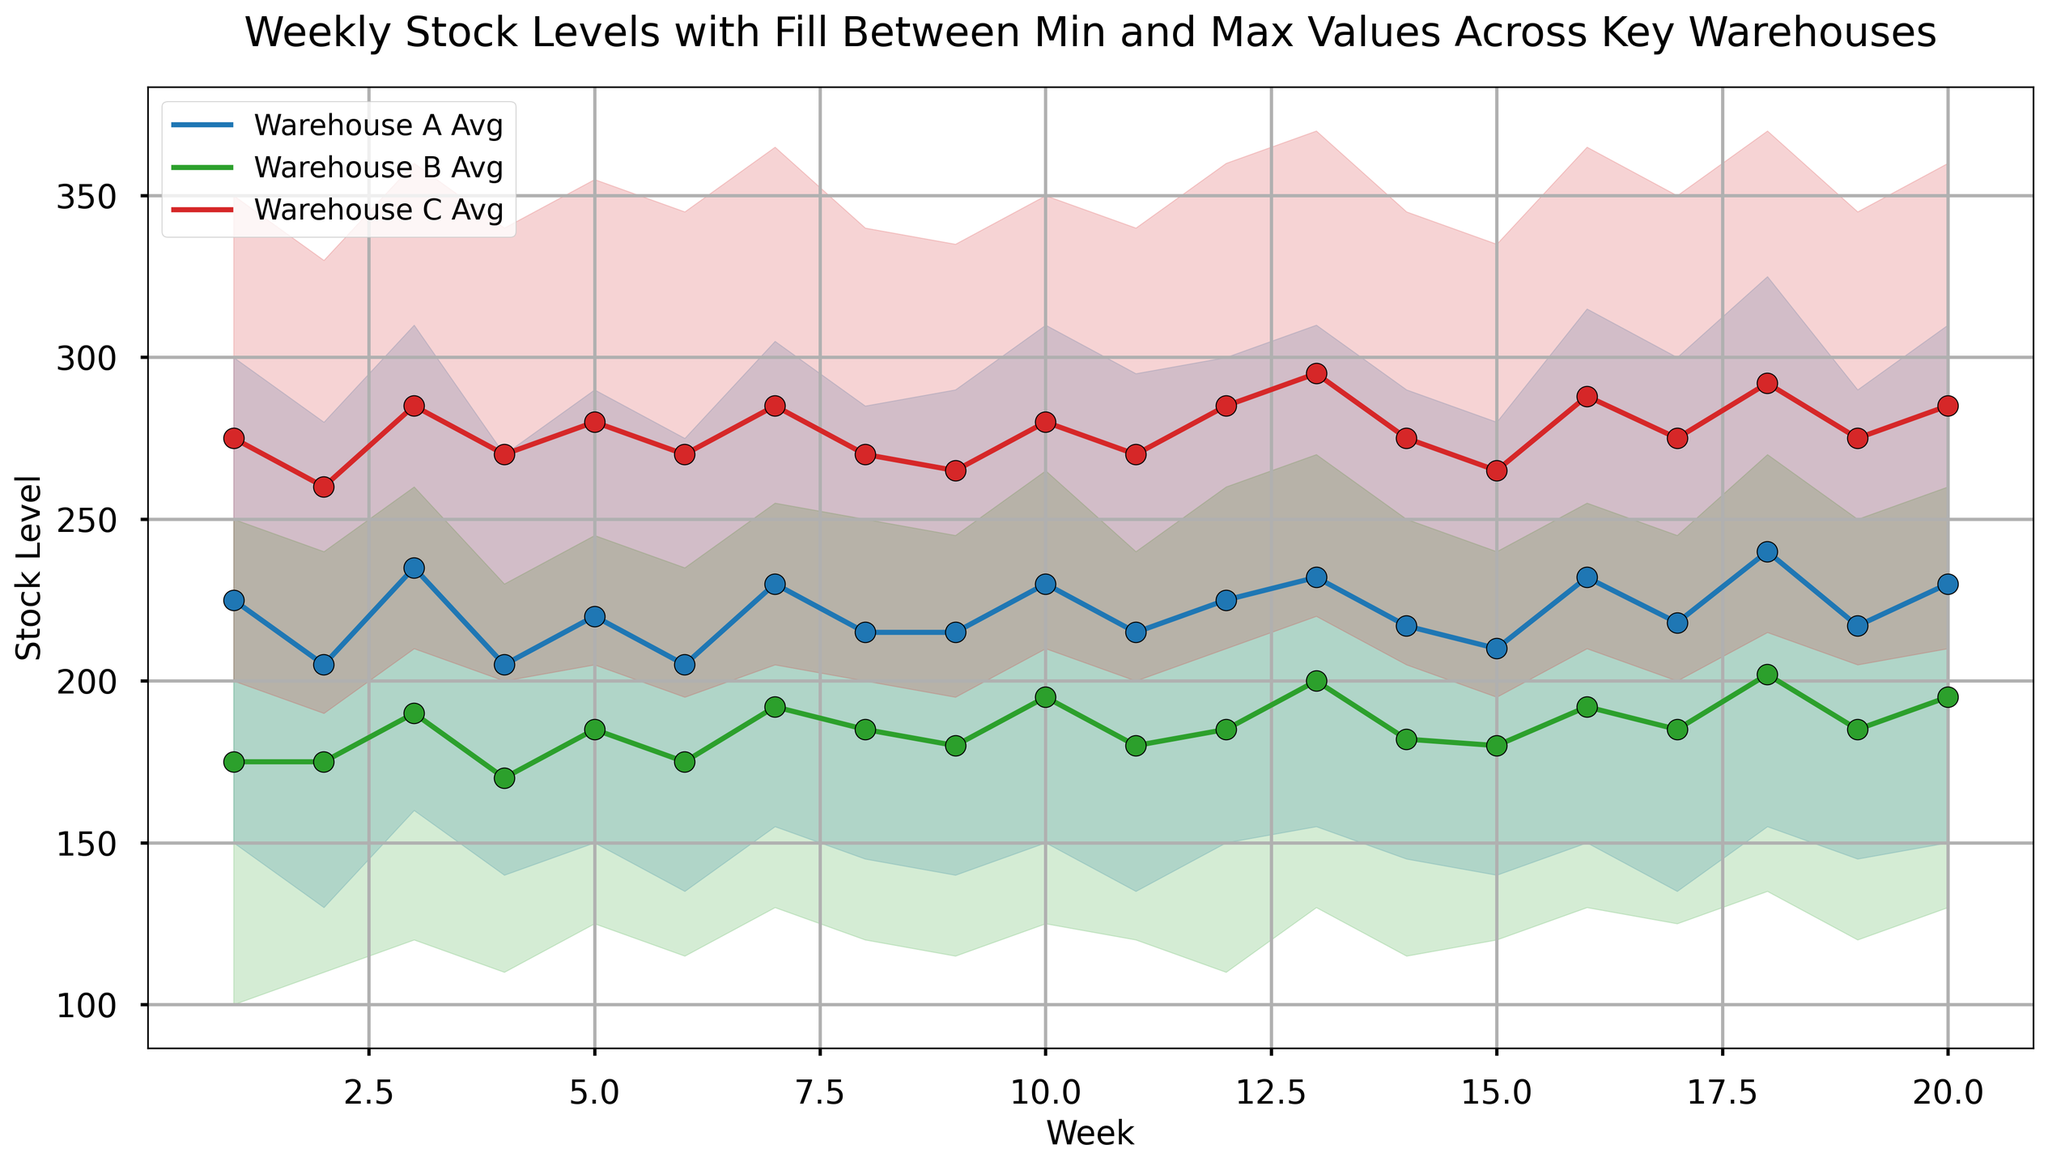What is the average stock level of Warehouse B in Week 10? To find the average stock level, look for the point on the Week 10 line for Warehouse B. The plot should label the average stock with a line; in Week 10, it is shown as either a point or a label on the graph.
Answer: 195 Which week had the highest maximum stock level for Warehouse C? Examine the upper boundary of the filled area for Warehouse C. The peak of this boundary indicates the highest maximum stock level. In this case, find the highest peak along the timeline for Warehouse C.
Answer: Week 13 and Week 18 How does the minimum stock level of Warehouse A in Week 3 compare to Warehouse B in the same week? Compare the lower boundary of the filled area for both Warehouse A and B in Week 3. The lower endpoint of the filled region indicates the minimum stock level.
Answer: Warehouse A has a higher minimum stock level than Warehouse B In which week does Warehouse C have the greatest difference between minimum and maximum stock levels? Compute the difference between the min and max stock levels for Warehouse C across all weeks by visually inspecting the filled area for the largest vertical distance.
Answer: Week 13 and Week 18 What's the trend of average stock levels for Warehouse A over the 20 weeks? Observe the line trajectory representing the average stock for Warehouse A. Trace its slope and changes over the weeks to identify an overall trend.
Answer: Generally increasing On average, is Warehouse B's stock level generally higher or lower than Warehouse A's over the 20 weeks? Compare the heights of the average stock lines (middle points) for Warehouse B and Warehouse A over the given range. Assess which line remains higher for most of the period.
Answer: Lower Which warehouse has the most stable stock levels, considering the min and max values? Stability is reflected in the narrowness of the filled region. Compare the widths of the filled regions across all three warehouses. The narrower the range, the more stable the stock levels.
Answer: Warehouse B What are the colors representing each warehouse in the plot? Identify the colors used to represent each warehouse by visually inspecting the plot legend or the lines and filled areas directly.
Answer: Warehouse A: Blue, Warehouse B: Green, Warehouse C: Red Which warehouse's average stock in Week 12 surpasses its maximum stock in Week 9? Compare the average stock values in Week 12 with the maximum stock values in Week 9 for each warehouse by looking at the respective lines and filled regions on those weeks.
Answer: None 